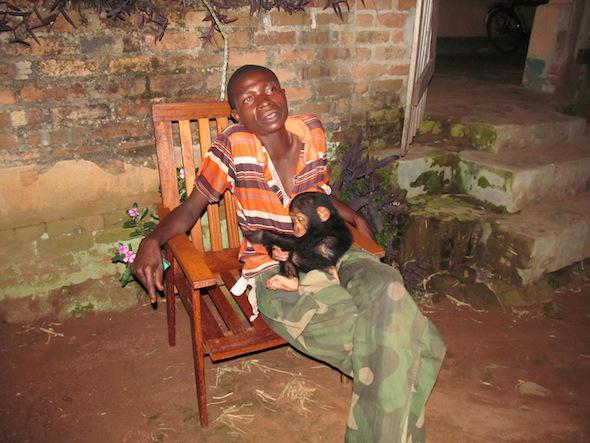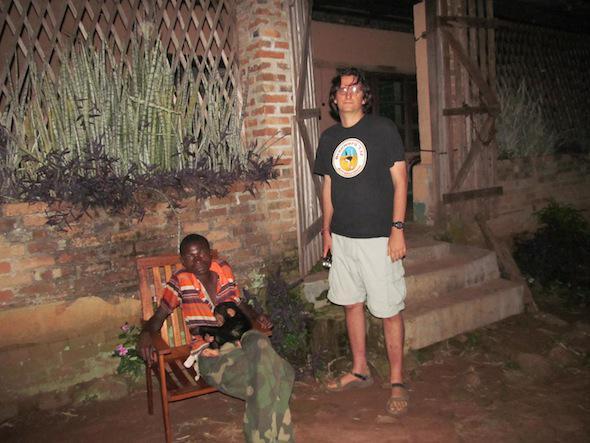The first image is the image on the left, the second image is the image on the right. For the images shown, is this caption "One image shows multiple chimps gathered around a prone figure on the ground in a clearing." true? Answer yes or no. No. The first image is the image on the left, the second image is the image on the right. Analyze the images presented: Is the assertion "There is a furniture near a chimpanzee in at least one of the images." valid? Answer yes or no. Yes. 